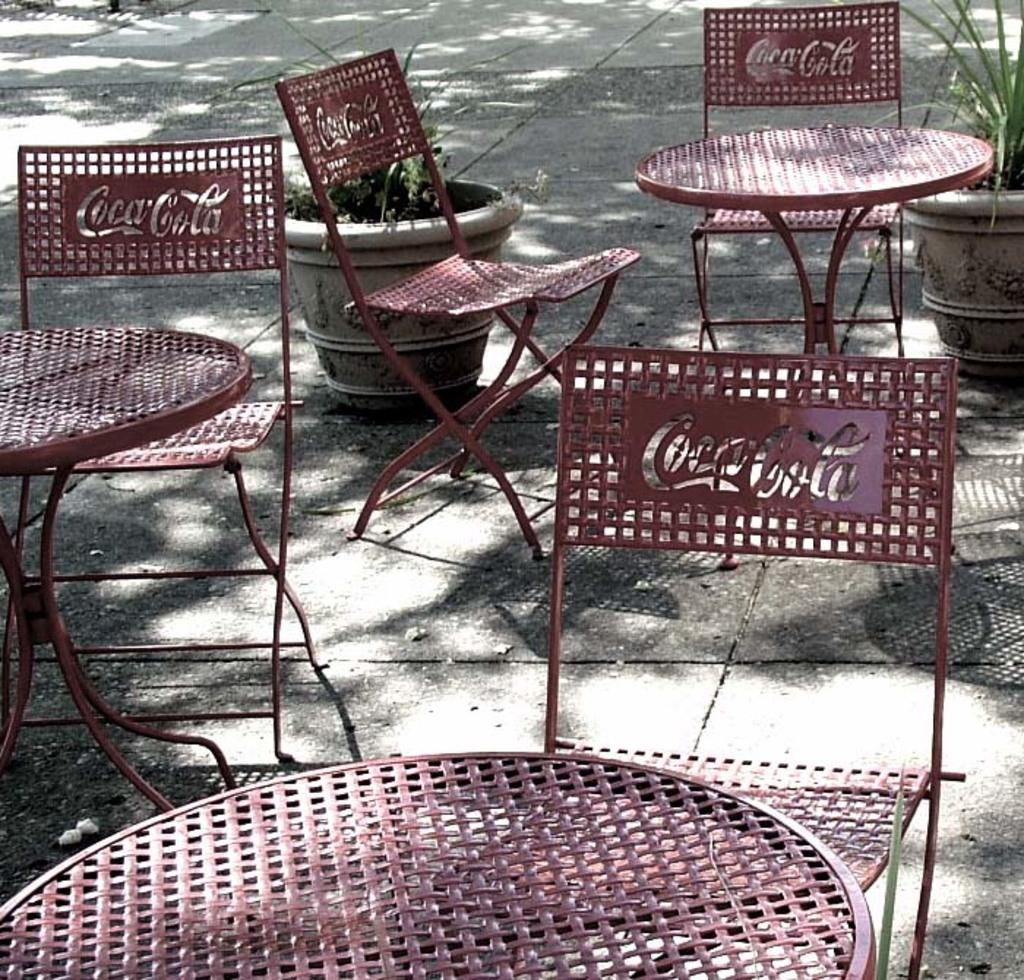What type of furniture is present in the image? There are tables and chairs in the image. What can be seen on the chairs? Something is written on at least one chair. What is visible in the background of the image? There are pots with plants in the background of the image. What type of jar is being used by the maid in the image? There is no jar or maid present in the image. How is the glue being applied to the chairs in the image? There is no glue or application process visible in the image. 